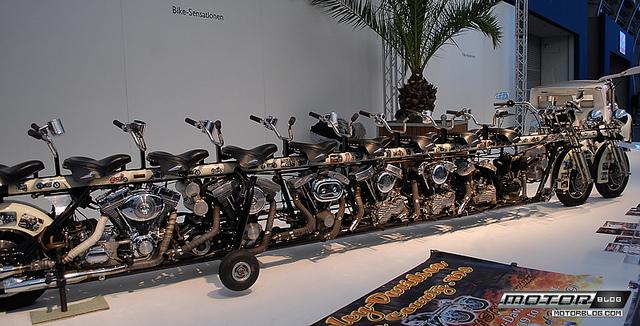Is there a palm tree?
Answer briefly. Yes. Are the bikes on a conveyor belt?
Answer briefly. Yes. What is parked in the racks?
Quick response, please. Bikes. Are these mopeds or motorcycles?
Concise answer only. Motorcycles. 